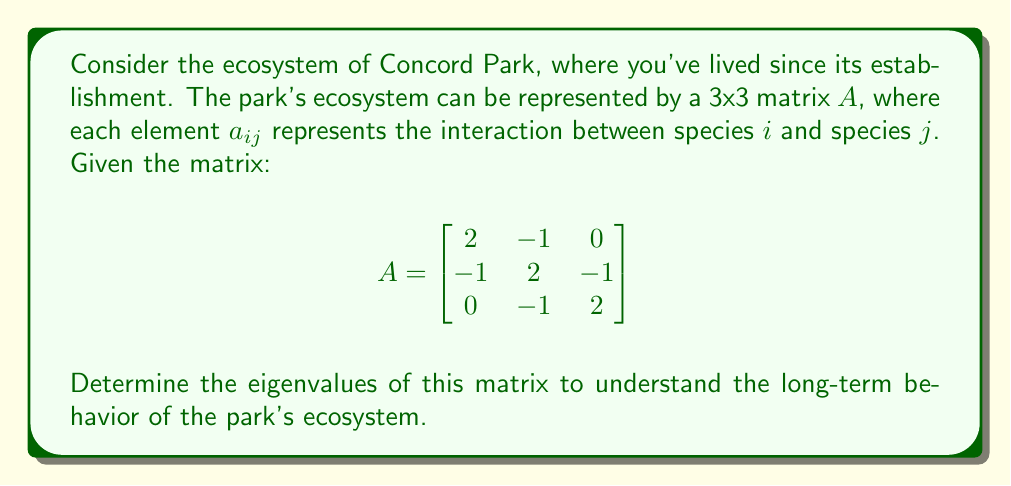Give your solution to this math problem. To find the eigenvalues of matrix $A$, we need to solve the characteristic equation:

1) First, we set up the equation $\det(A - \lambda I) = 0$, where $I$ is the 3x3 identity matrix:

   $$\det\begin{bmatrix}
   2-\lambda & -1 & 0 \\
   -1 & 2-\lambda & -1 \\
   0 & -1 & 2-\lambda
   \end{bmatrix} = 0$$

2) Expand the determinant:
   $$(2-\lambda)[(2-\lambda)(2-\lambda) - 1] - (-1)[(-1)(2-\lambda) - 0] = 0$$

3) Simplify:
   $$(2-\lambda)[(2-\lambda)^2 - 1] + (2-\lambda) = 0$$
   $$(2-\lambda)[(2-\lambda)^2 - 1 + 1] = 0$$
   $$(2-\lambda)(2-\lambda)^2 = 0$$

4) Factor the equation:
   $(2-\lambda)(2-\lambda)(2-\lambda) = 0$

5) Solve for $\lambda$:
   $\lambda = 2$ (with algebraic multiplicity 3)

Therefore, the only eigenvalue is 2, with algebraic multiplicity 3.
Answer: $\lambda = 2$ (multiplicity 3) 